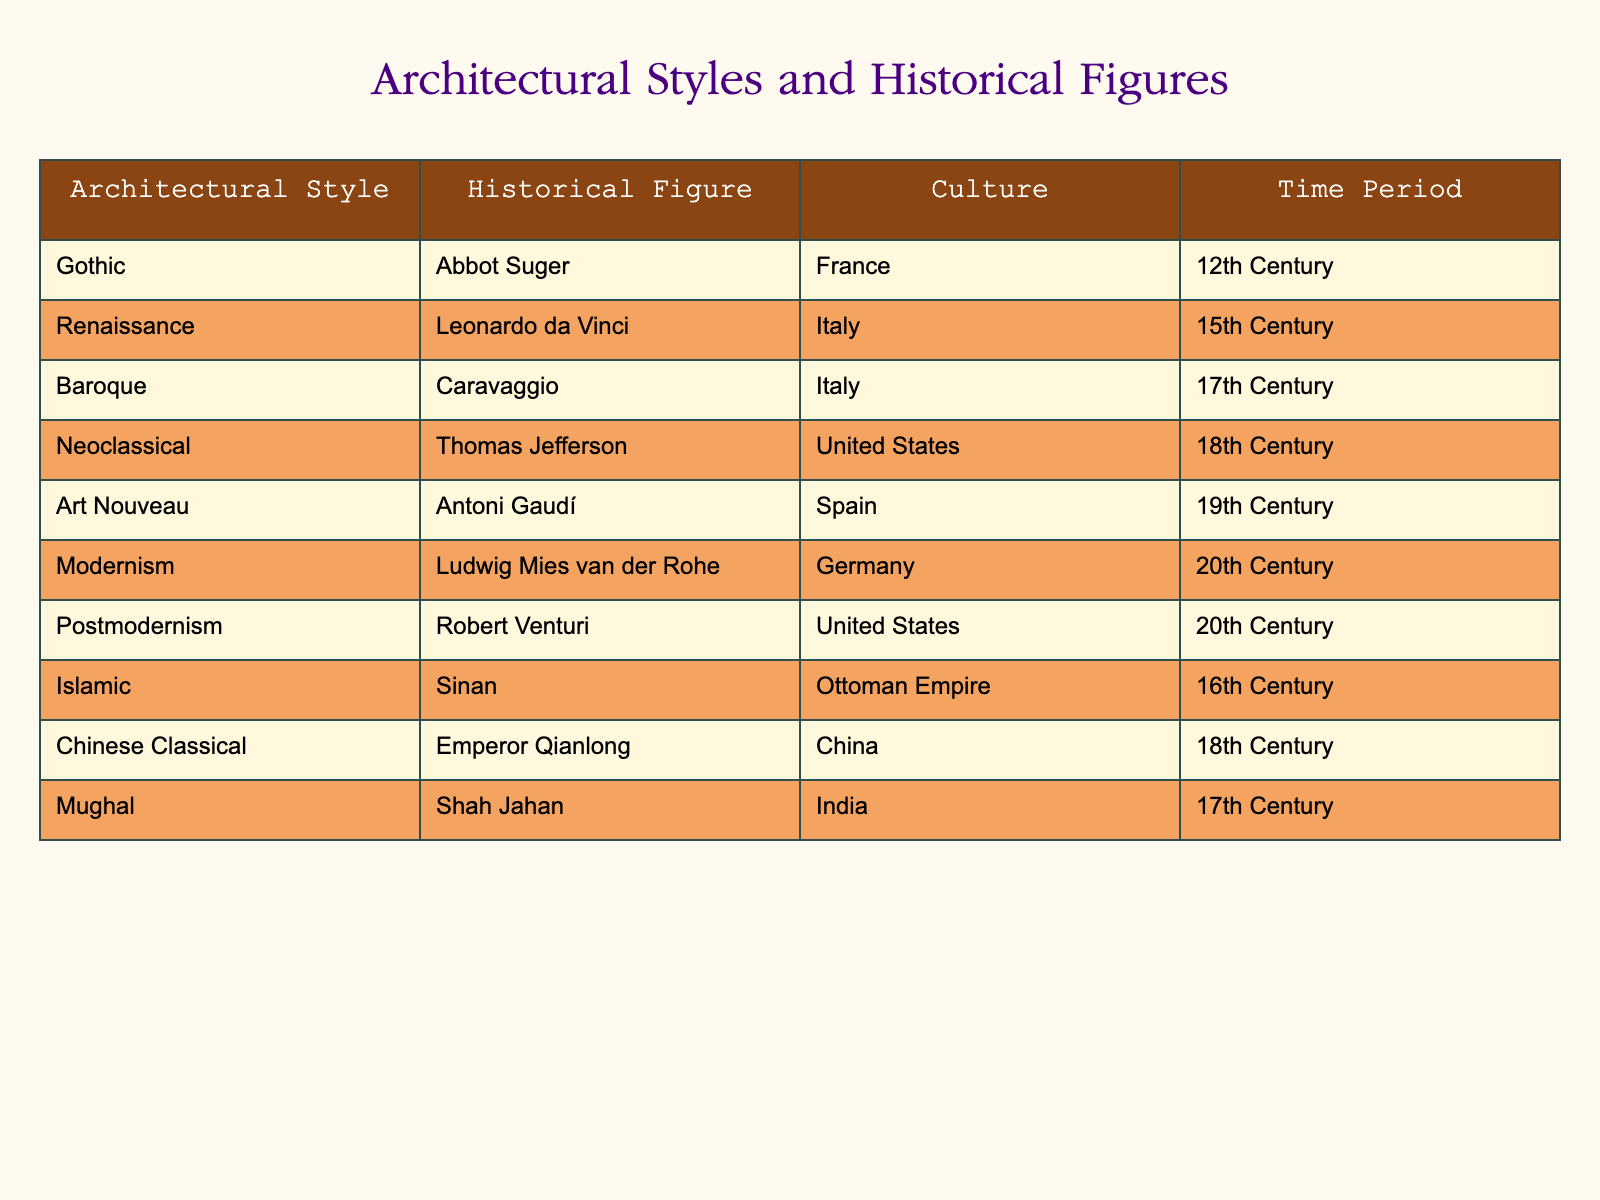What architectural style is associated with Abbot Suger? The table clearly indicates that Abbot Suger is associated with the Gothic architectural style, as mentioned in the first row of the table.
Answer: Gothic Which historical figure is linked to the Neoclassical architectural style? Referring to the table, the Neoclassical architectural style is associated with Thomas Jefferson, as seen in the fourth row.
Answer: Thomas Jefferson Are there more architectural styles from the 17th century than from the 18th century? The table shows two styles from the 17th century (Baroque and Mughal) and two from the 18th century (Neoclassical and Chinese Classical). Therefore, both centuries have an equal number of styles.
Answer: No Which architectural styles are linked to the United States? By examining the table, the architectural styles linked to the United States are Neoclassical and Postmodernism, associated with Thomas Jefferson and Robert Venturi, respectively.
Answer: Neoclassical, Postmodernism What is the time period of the architectural style associated with Antoni Gaudí? The table states that the architectural style linked to Antoni Gaudí, which is Art Nouveau, is from the 19th century.
Answer: 19th Century How many architectural styles listed are associated with Italy? The table lists three architectural styles associated with Italy: Renaissance, Baroque, and the fact that both are linked to Leonardo da Vinci and Caravaggio respectively.
Answer: 2 Is there an architectural style from China that corresponds to a figure from the 18th century? According to the table, there is indeed a style from China, Chinese Classical, that corresponds to Emperor Qianlong, who lived during the 18th century.
Answer: Yes What is the average time period of the architectural styles represented in this table? The table reflects a variety of centuries: 12th, 15th, 17th (twice), 18th (twice), 19th, and 20th (twice). Calculating the average: (12 + 15 + 17 + 17 + 18 + 18 + 19 + 20 + 20) / 9 equals approximately 17.11, which rounds to 17.
Answer: 17 How many architectural styles are represented in the table? Counting each row in the table shows there are ten architectural styles represented, each corresponding to a different historical figure.
Answer: 10 